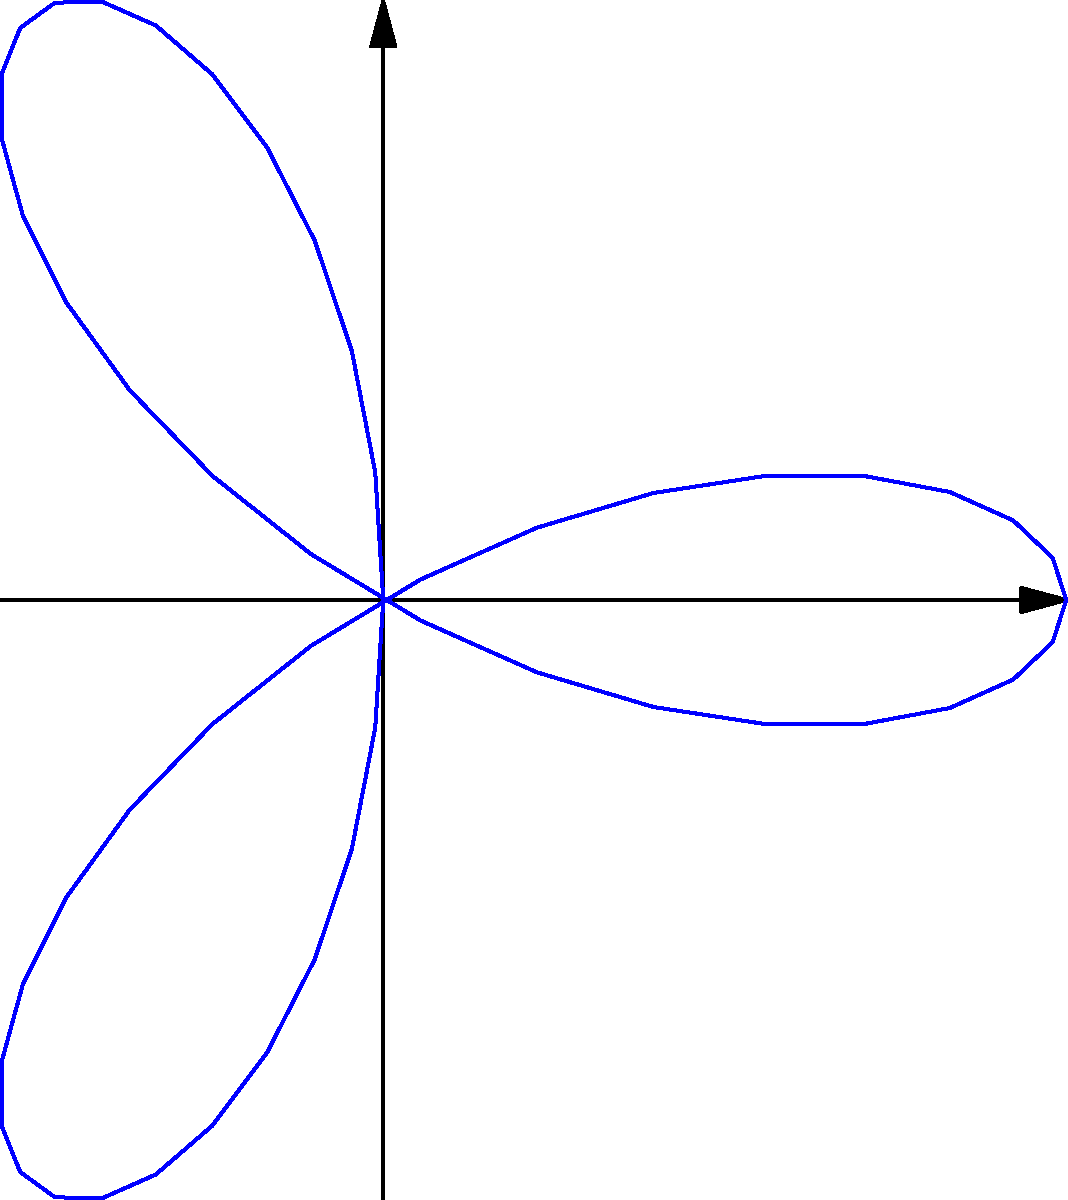You're tasked with calculating the area enclosed by a polar rose curve given by the equation $r = 2\cos(3\theta)$. What is the area of this curve? (Round your answer to two decimal places) To calculate the area enclosed by a polar rose curve, we can use the formula:

$$A = \frac{1}{2} \int_{0}^{2\pi} r^2 d\theta$$

For our curve, $r = 2\cos(3\theta)$. Let's follow these steps:

1) Substitute $r$ into the formula:
   $$A = \frac{1}{2} \int_{0}^{2\pi} (2\cos(3\theta))^2 d\theta$$

2) Simplify the integrand:
   $$A = \frac{1}{2} \int_{0}^{2\pi} 4\cos^2(3\theta) d\theta$$

3) Use the trigonometric identity $\cos^2 x = \frac{1 + \cos(2x)}{2}$:
   $$A = \frac{1}{2} \int_{0}^{2\pi} 4 \cdot \frac{1 + \cos(6\theta)}{2} d\theta$$

4) Simplify:
   $$A = \int_{0}^{2\pi} (1 + \cos(6\theta)) d\theta$$

5) Integrate:
   $$A = [\theta + \frac{1}{6}\sin(6\theta)]_{0}^{2\pi}$$

6) Evaluate the integral:
   $$A = (2\pi + 0) - (0 + 0) = 2\pi$$

7) Calculate the numerical value and round to two decimal places:
   $$A \approx 6.28$$
Answer: 6.28 